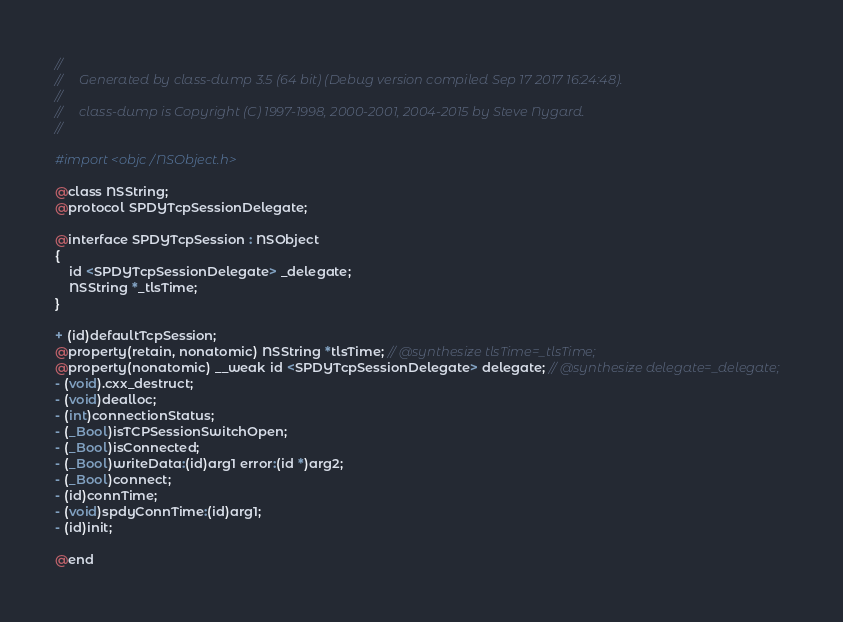<code> <loc_0><loc_0><loc_500><loc_500><_C_>//
//     Generated by class-dump 3.5 (64 bit) (Debug version compiled Sep 17 2017 16:24:48).
//
//     class-dump is Copyright (C) 1997-1998, 2000-2001, 2004-2015 by Steve Nygard.
//

#import <objc/NSObject.h>

@class NSString;
@protocol SPDYTcpSessionDelegate;

@interface SPDYTcpSession : NSObject
{
    id <SPDYTcpSessionDelegate> _delegate;
    NSString *_tlsTime;
}

+ (id)defaultTcpSession;
@property(retain, nonatomic) NSString *tlsTime; // @synthesize tlsTime=_tlsTime;
@property(nonatomic) __weak id <SPDYTcpSessionDelegate> delegate; // @synthesize delegate=_delegate;
- (void).cxx_destruct;
- (void)dealloc;
- (int)connectionStatus;
- (_Bool)isTCPSessionSwitchOpen;
- (_Bool)isConnected;
- (_Bool)writeData:(id)arg1 error:(id *)arg2;
- (_Bool)connect;
- (id)connTime;
- (void)spdyConnTime:(id)arg1;
- (id)init;

@end

</code> 